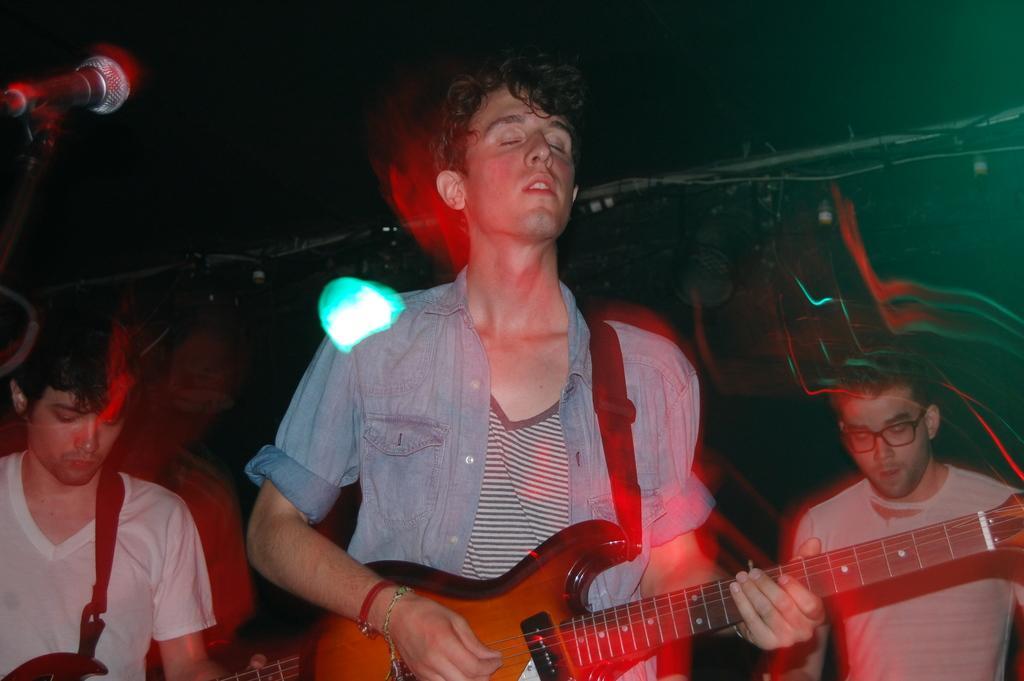In one or two sentences, can you explain what this image depicts? In this picture we can see a three men where two are holding guitars in their hands and playing and other worn spectacle and in front of them we have mic and in background we can see pipes, wires and it is dark. 